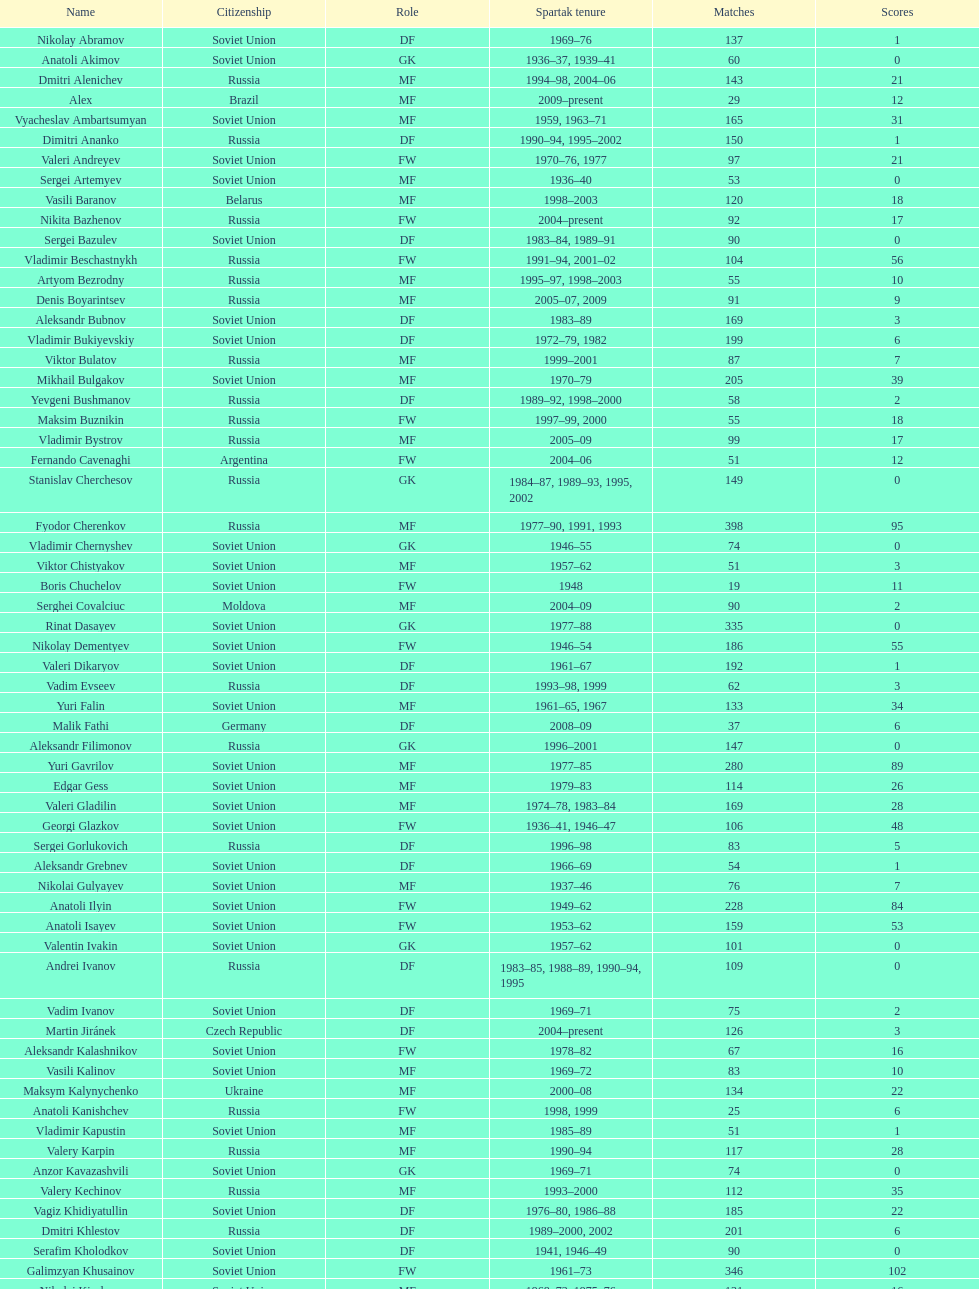Name two players with goals above 15. Dmitri Alenichev, Vyacheslav Ambartsumyan. 